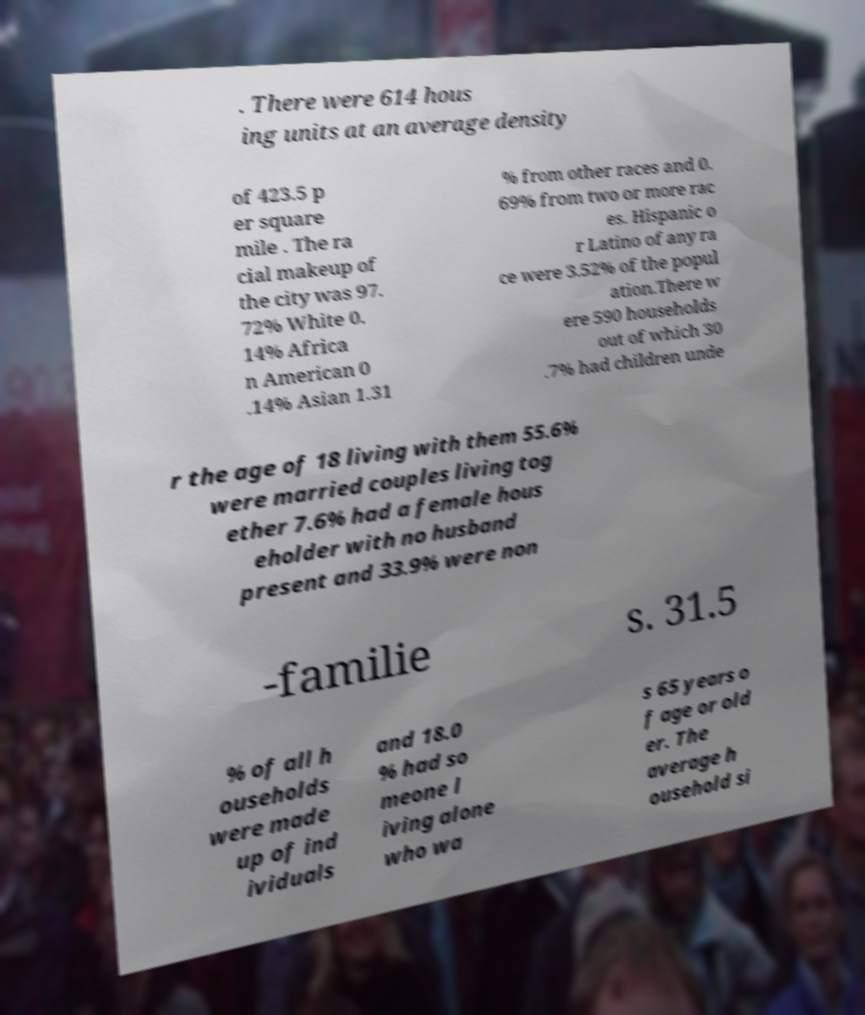I need the written content from this picture converted into text. Can you do that? . There were 614 hous ing units at an average density of 423.5 p er square mile . The ra cial makeup of the city was 97. 72% White 0. 14% Africa n American 0 .14% Asian 1.31 % from other races and 0. 69% from two or more rac es. Hispanic o r Latino of any ra ce were 3.52% of the popul ation.There w ere 590 households out of which 30 .7% had children unde r the age of 18 living with them 55.6% were married couples living tog ether 7.6% had a female hous eholder with no husband present and 33.9% were non -familie s. 31.5 % of all h ouseholds were made up of ind ividuals and 18.0 % had so meone l iving alone who wa s 65 years o f age or old er. The average h ousehold si 